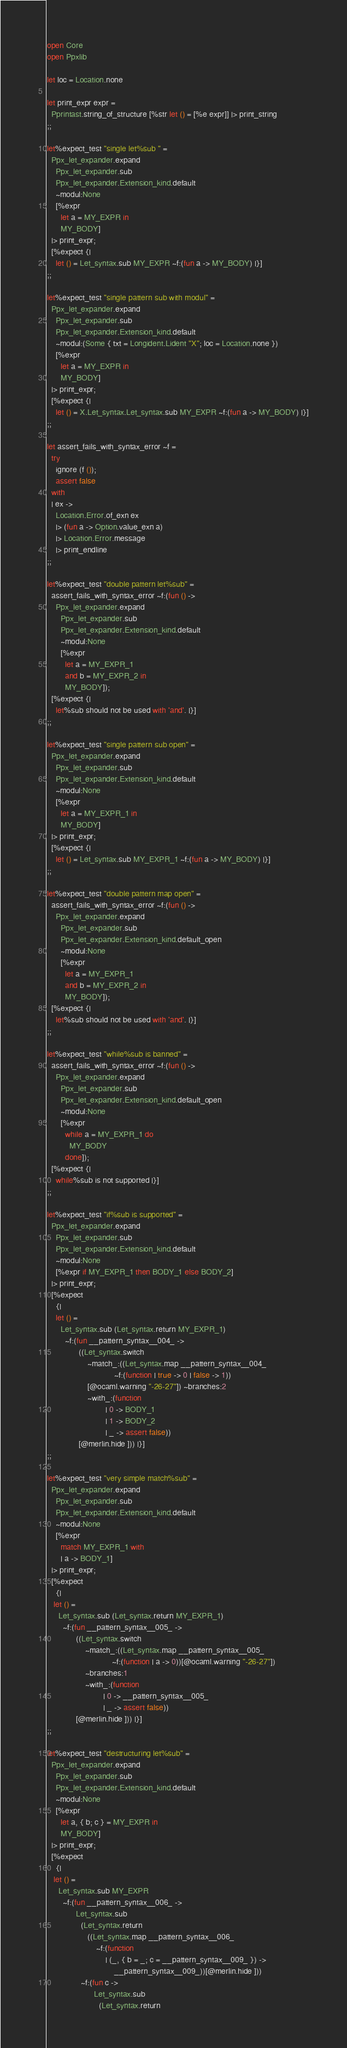<code> <loc_0><loc_0><loc_500><loc_500><_OCaml_>open Core
open Ppxlib

let loc = Location.none

let print_expr expr =
  Pprintast.string_of_structure [%str let () = [%e expr]] |> print_string
;;

let%expect_test "single let%sub " =
  Ppx_let_expander.expand
    Ppx_let_expander.sub
    Ppx_let_expander.Extension_kind.default
    ~modul:None
    [%expr
      let a = MY_EXPR in
      MY_BODY]
  |> print_expr;
  [%expect {|
    let () = Let_syntax.sub MY_EXPR ~f:(fun a -> MY_BODY) |}]
;;

let%expect_test "single pattern sub with modul" =
  Ppx_let_expander.expand
    Ppx_let_expander.sub
    Ppx_let_expander.Extension_kind.default
    ~modul:(Some { txt = Longident.Lident "X"; loc = Location.none })
    [%expr
      let a = MY_EXPR in
      MY_BODY]
  |> print_expr;
  [%expect {|
    let () = X.Let_syntax.Let_syntax.sub MY_EXPR ~f:(fun a -> MY_BODY) |}]
;;

let assert_fails_with_syntax_error ~f =
  try
    ignore (f ());
    assert false
  with
  | ex ->
    Location.Error.of_exn ex
    |> (fun a -> Option.value_exn a)
    |> Location.Error.message
    |> print_endline
;;

let%expect_test "double pattern let%sub" =
  assert_fails_with_syntax_error ~f:(fun () ->
    Ppx_let_expander.expand
      Ppx_let_expander.sub
      Ppx_let_expander.Extension_kind.default
      ~modul:None
      [%expr
        let a = MY_EXPR_1
        and b = MY_EXPR_2 in
        MY_BODY]);
  [%expect {|
    let%sub should not be used with 'and'. |}]
;;

let%expect_test "single pattern sub open" =
  Ppx_let_expander.expand
    Ppx_let_expander.sub
    Ppx_let_expander.Extension_kind.default
    ~modul:None
    [%expr
      let a = MY_EXPR_1 in
      MY_BODY]
  |> print_expr;
  [%expect {|
    let () = Let_syntax.sub MY_EXPR_1 ~f:(fun a -> MY_BODY) |}]
;;

let%expect_test "double pattern map open" =
  assert_fails_with_syntax_error ~f:(fun () ->
    Ppx_let_expander.expand
      Ppx_let_expander.sub
      Ppx_let_expander.Extension_kind.default_open
      ~modul:None
      [%expr
        let a = MY_EXPR_1
        and b = MY_EXPR_2 in
        MY_BODY]);
  [%expect {|
    let%sub should not be used with 'and'. |}]
;;

let%expect_test "while%sub is banned" =
  assert_fails_with_syntax_error ~f:(fun () ->
    Ppx_let_expander.expand
      Ppx_let_expander.sub
      Ppx_let_expander.Extension_kind.default_open
      ~modul:None
      [%expr
        while a = MY_EXPR_1 do
          MY_BODY
        done]);
  [%expect {|
    while%sub is not supported |}]
;;

let%expect_test "if%sub is supported" =
  Ppx_let_expander.expand
    Ppx_let_expander.sub
    Ppx_let_expander.Extension_kind.default
    ~modul:None
    [%expr if MY_EXPR_1 then BODY_1 else BODY_2]
  |> print_expr;
  [%expect
    {|
    let () =
      Let_syntax.sub (Let_syntax.return MY_EXPR_1)
        ~f:(fun __pattern_syntax__004_ ->
              ((Let_syntax.switch
                  ~match_:((Let_syntax.map __pattern_syntax__004_
                              ~f:(function | true -> 0 | false -> 1))
                  [@ocaml.warning "-26-27"]) ~branches:2
                  ~with_:(function
                          | 0 -> BODY_1
                          | 1 -> BODY_2
                          | _ -> assert false))
              [@merlin.hide ])) |}]
;;

let%expect_test "very simple match%sub" =
  Ppx_let_expander.expand
    Ppx_let_expander.sub
    Ppx_let_expander.Extension_kind.default
    ~modul:None
    [%expr
      match MY_EXPR_1 with
      | a -> BODY_1]
  |> print_expr;
  [%expect
    {|
   let () =
     Let_syntax.sub (Let_syntax.return MY_EXPR_1)
       ~f:(fun __pattern_syntax__005_ ->
             ((Let_syntax.switch
                 ~match_:((Let_syntax.map __pattern_syntax__005_
                             ~f:(function | a -> 0))[@ocaml.warning "-26-27"])
                 ~branches:1
                 ~with_:(function
                         | 0 -> __pattern_syntax__005_
                         | _ -> assert false))
             [@merlin.hide ])) |}]
;;

let%expect_test "destructuring let%sub" =
  Ppx_let_expander.expand
    Ppx_let_expander.sub
    Ppx_let_expander.Extension_kind.default
    ~modul:None
    [%expr
      let a, { b; c } = MY_EXPR in
      MY_BODY]
  |> print_expr;
  [%expect
    {|
   let () =
     Let_syntax.sub MY_EXPR
       ~f:(fun __pattern_syntax__006_ ->
             Let_syntax.sub
               (Let_syntax.return
                  ((Let_syntax.map __pattern_syntax__006_
                      ~f:(function
                          | (_, { b = _; c = __pattern_syntax__009_ }) ->
                              __pattern_syntax__009_))[@merlin.hide ]))
               ~f:(fun c ->
                     Let_syntax.sub
                       (Let_syntax.return</code> 